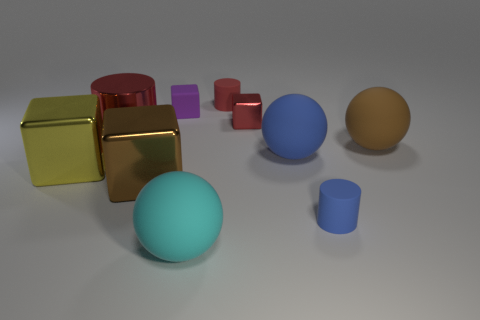What is the shape of the tiny shiny object that is the same color as the large shiny cylinder?
Give a very brief answer. Cube. Are there more big brown rubber things behind the large yellow block than red objects that are left of the red matte cylinder?
Offer a terse response. No. Is the yellow metal object the same size as the brown metal object?
Your answer should be very brief. Yes. What is the color of the other tiny rubber object that is the same shape as the small red matte object?
Provide a succinct answer. Blue. How many metallic blocks have the same color as the metal cylinder?
Provide a succinct answer. 1. Is the number of large cyan objects that are behind the tiny blue cylinder greater than the number of yellow rubber spheres?
Ensure brevity in your answer.  No. What is the color of the big matte object in front of the matte cylinder in front of the big yellow shiny thing?
Keep it short and to the point. Cyan. How many objects are red metallic blocks that are left of the small blue object or cylinders behind the brown matte ball?
Ensure brevity in your answer.  3. The large metallic cylinder is what color?
Ensure brevity in your answer.  Red. How many other yellow objects have the same material as the yellow thing?
Give a very brief answer. 0. 